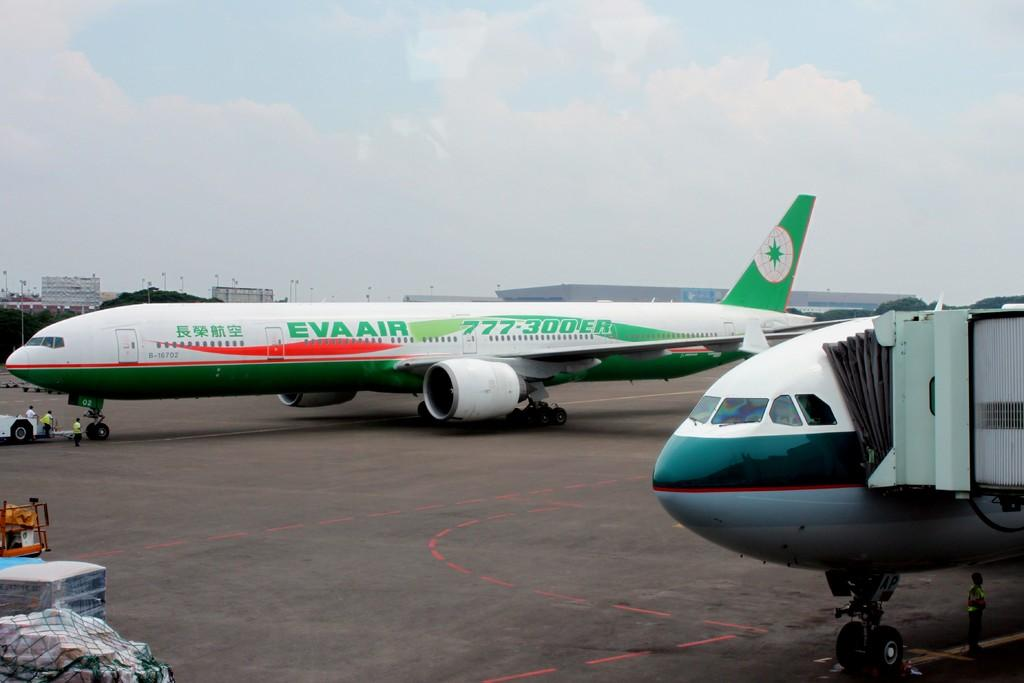What is unusual about the scene in the image? There are two aeroplanes on the road, which is not a typical location for them. What can be seen in the background of the image? There are buildings in the background. What is visible in the sky in the image? The sky is visible, and clouds are present. What degree does the insurance agent have in the image? There is no insurance agent or degree mentioned in the image. The image features two aeroplanes on the road, buildings in the background, and clouds in the sky. 